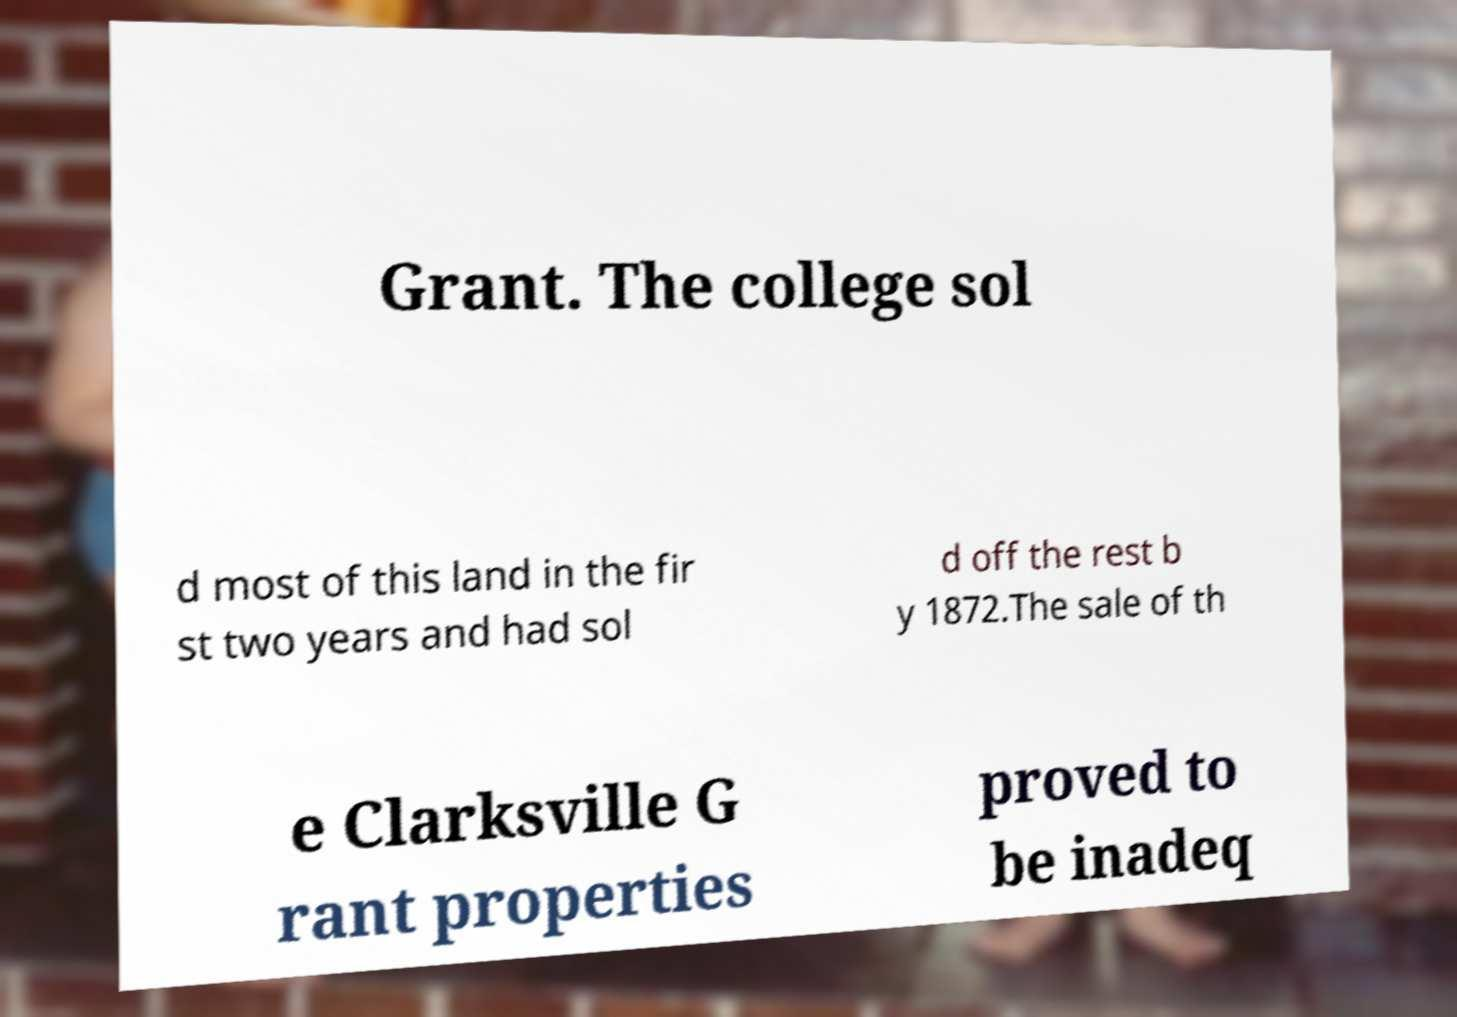Could you extract and type out the text from this image? Grant. The college sol d most of this land in the fir st two years and had sol d off the rest b y 1872.The sale of th e Clarksville G rant properties proved to be inadeq 